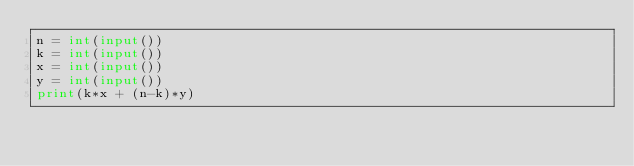Convert code to text. <code><loc_0><loc_0><loc_500><loc_500><_Python_>n = int(input())
k = int(input())
x = int(input())
y = int(input())
print(k*x + (n-k)*y)</code> 